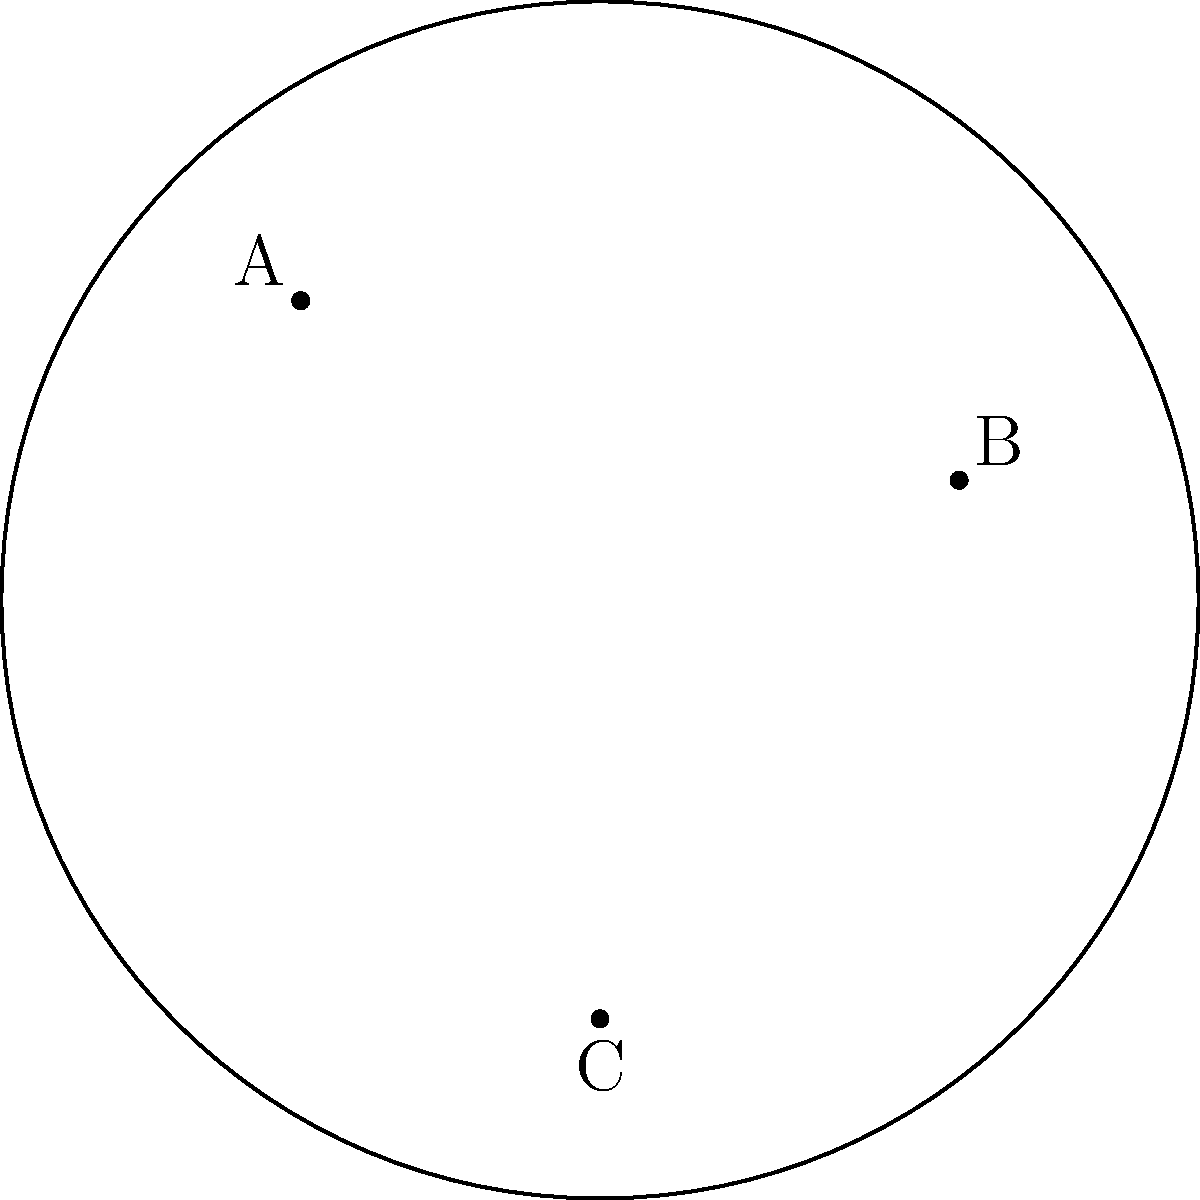In the Poincaré disk model of hyperbolic geometry shown above, three major plot twists (A, B, and C) in your novel are represented as points. The hyperbolic lines connecting these points represent the narrative paths between twists. If the hyperbolic distance between points A and B is 1.2, B and C is 0.9, and A and C is 1.5, what is the area of the hyperbolic triangle ABC? (Assume the radius of the Poincaré disk is 1.) To solve this problem, we'll use the hyperbolic law of cosines and the formula for the area of a hyperbolic triangle:

1) First, we need to find the angles of the hyperbolic triangle using the hyperbolic law of cosines:

   $\cosh c = \cosh a \cosh b - \sinh a \sinh b \cos C$

   Where a, b, and c are the lengths of the sides, and C is the angle opposite side c.

2) Let's calculate angle A:
   $\cosh 1.5 = \cosh 1.2 \cosh 0.9 - \sinh 1.2 \sinh 0.9 \cos A$
   $\cos A = \frac{\cosh 1.2 \cosh 0.9 - \cosh 1.5}{\sinh 1.2 \sinh 0.9}$

3) Similarly, we can calculate angles B and C.

4) Once we have the angles, we can use the formula for the area of a hyperbolic triangle:

   $Area = \pi - (A + B + C)$

   Where A, B, and C are the angles in radians.

5) Calculate the area by subtracting the sum of the angles from π.

Note: The exact calculation would require numerical methods, as the hyperbolic functions don't have simple closed-form solutions.
Answer: $\pi - (A + B + C)$, where A, B, and C are the angles calculated using the hyperbolic law of cosines. 